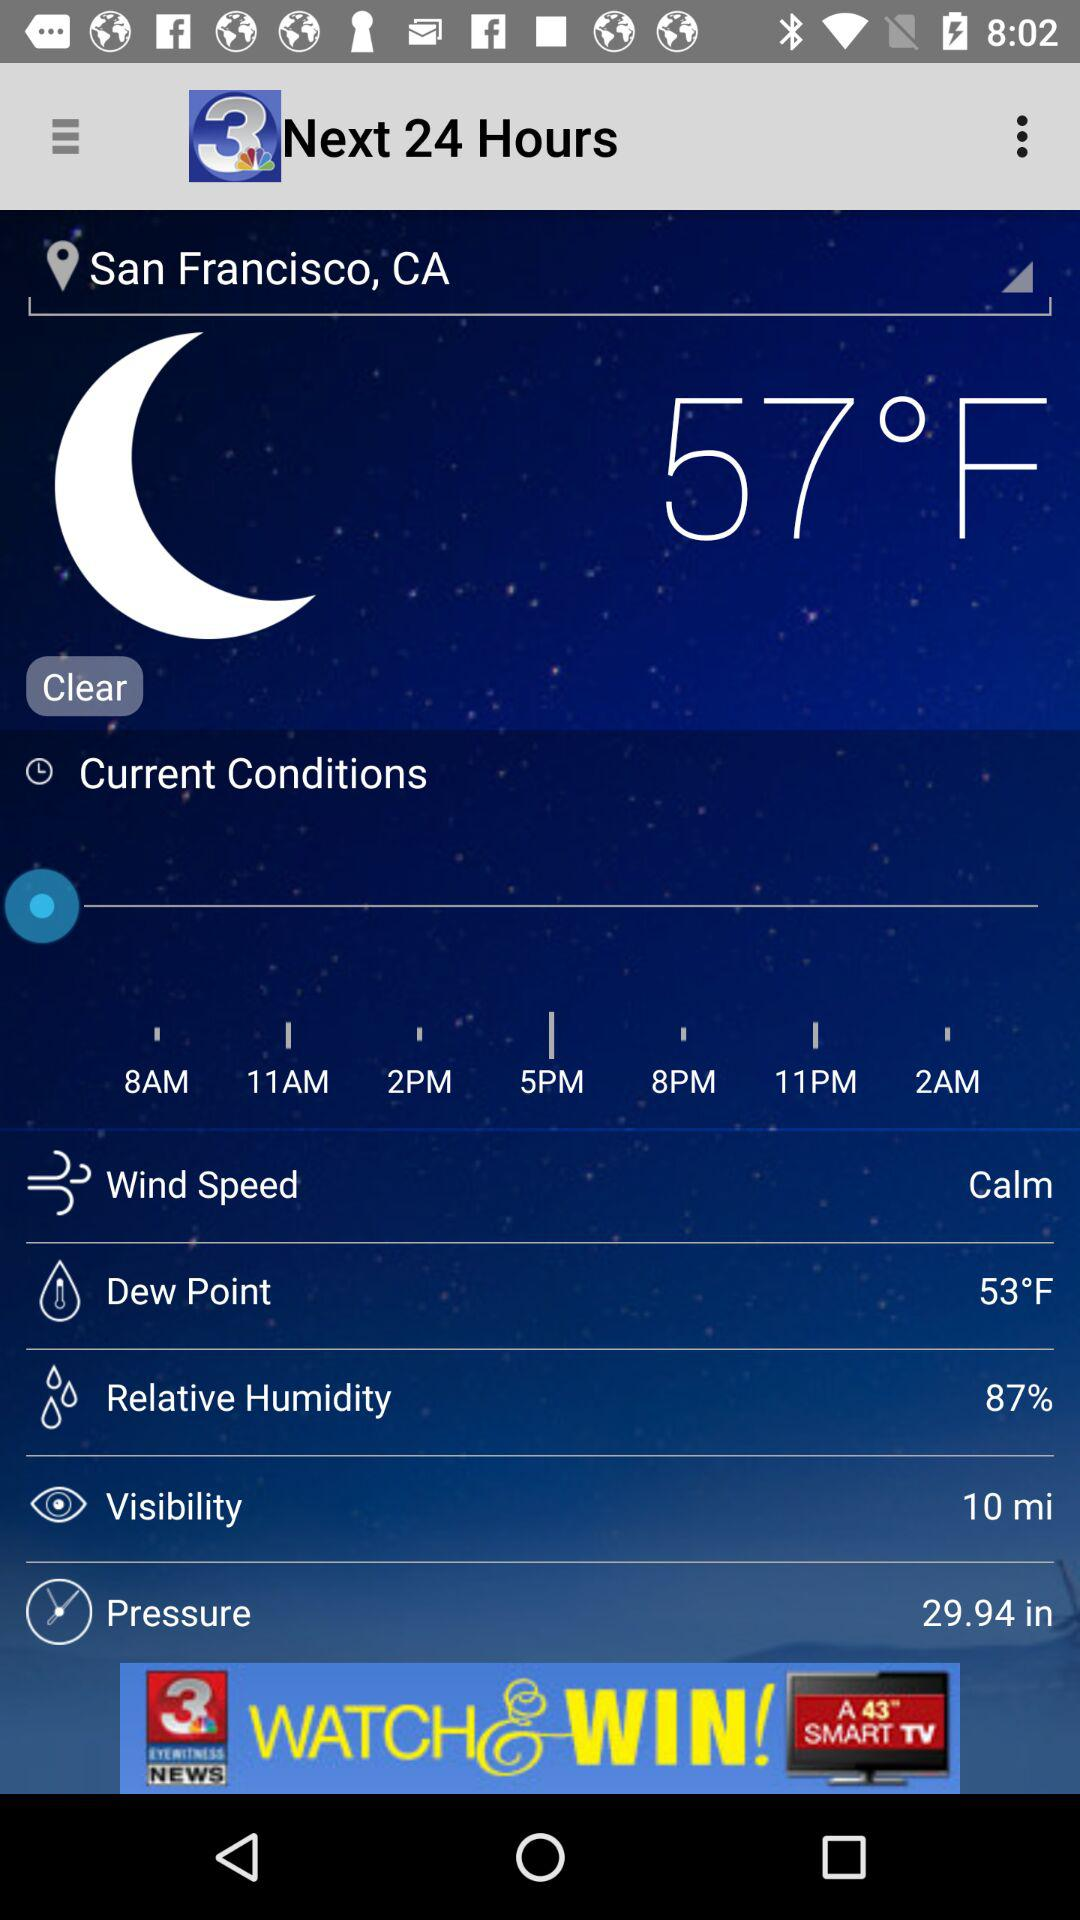What is the humidity percentage?
Answer the question using a single word or phrase. 87% 